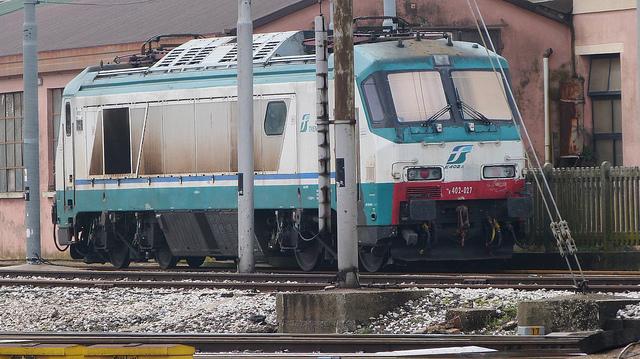Does this train appear to be brand new?
Quick response, please. No. Is this a railway station in the countryside?
Answer briefly. Yes. Does the train have window wipes?
Keep it brief. Yes. 